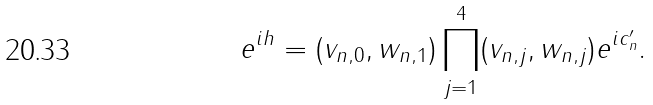Convert formula to latex. <formula><loc_0><loc_0><loc_500><loc_500>e ^ { i h } = ( v _ { n , 0 } , w _ { n , 1 } ) \prod _ { j = 1 } ^ { 4 } ( v _ { n , j } , w _ { n , j } ) e ^ { i c _ { n } ^ { \prime } } .</formula> 